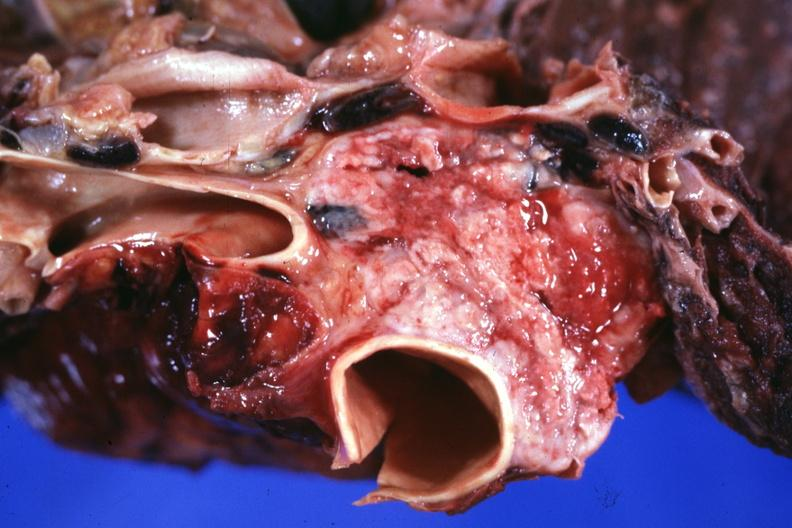does this image show section through mediastinum to show tumor surrounding vessels?
Answer the question using a single word or phrase. Yes 